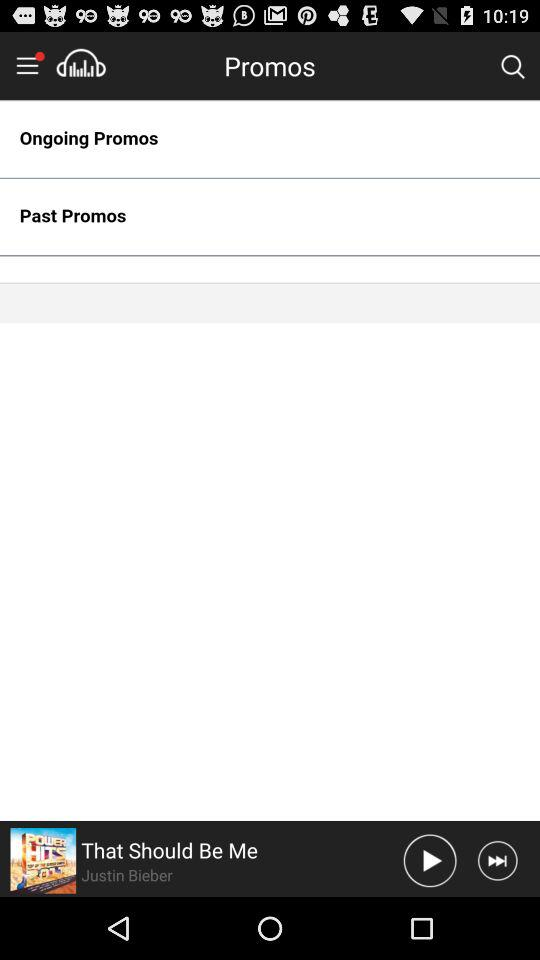What is the name of the currently playing song? The name of the currently playing song is "That Should Be Me". 